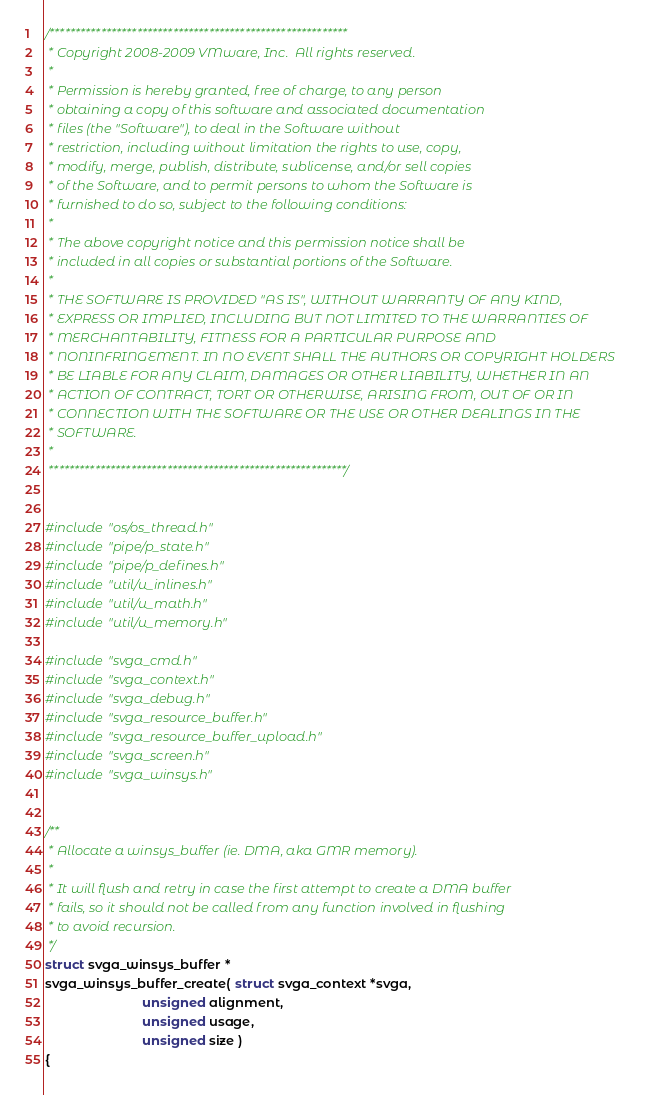<code> <loc_0><loc_0><loc_500><loc_500><_C_>/**********************************************************
 * Copyright 2008-2009 VMware, Inc.  All rights reserved.
 *
 * Permission is hereby granted, free of charge, to any person
 * obtaining a copy of this software and associated documentation
 * files (the "Software"), to deal in the Software without
 * restriction, including without limitation the rights to use, copy,
 * modify, merge, publish, distribute, sublicense, and/or sell copies
 * of the Software, and to permit persons to whom the Software is
 * furnished to do so, subject to the following conditions:
 *
 * The above copyright notice and this permission notice shall be
 * included in all copies or substantial portions of the Software.
 *
 * THE SOFTWARE IS PROVIDED "AS IS", WITHOUT WARRANTY OF ANY KIND,
 * EXPRESS OR IMPLIED, INCLUDING BUT NOT LIMITED TO THE WARRANTIES OF
 * MERCHANTABILITY, FITNESS FOR A PARTICULAR PURPOSE AND
 * NONINFRINGEMENT. IN NO EVENT SHALL THE AUTHORS OR COPYRIGHT HOLDERS
 * BE LIABLE FOR ANY CLAIM, DAMAGES OR OTHER LIABILITY, WHETHER IN AN
 * ACTION OF CONTRACT, TORT OR OTHERWISE, ARISING FROM, OUT OF OR IN
 * CONNECTION WITH THE SOFTWARE OR THE USE OR OTHER DEALINGS IN THE
 * SOFTWARE.
 *
 **********************************************************/


#include "os/os_thread.h"
#include "pipe/p_state.h"
#include "pipe/p_defines.h"
#include "util/u_inlines.h"
#include "util/u_math.h"
#include "util/u_memory.h"

#include "svga_cmd.h"
#include "svga_context.h"
#include "svga_debug.h"
#include "svga_resource_buffer.h"
#include "svga_resource_buffer_upload.h"
#include "svga_screen.h"
#include "svga_winsys.h"


/**
 * Allocate a winsys_buffer (ie. DMA, aka GMR memory).
 *
 * It will flush and retry in case the first attempt to create a DMA buffer
 * fails, so it should not be called from any function involved in flushing
 * to avoid recursion.
 */
struct svga_winsys_buffer *
svga_winsys_buffer_create( struct svga_context *svga,
                           unsigned alignment,
                           unsigned usage,
                           unsigned size )
{</code> 